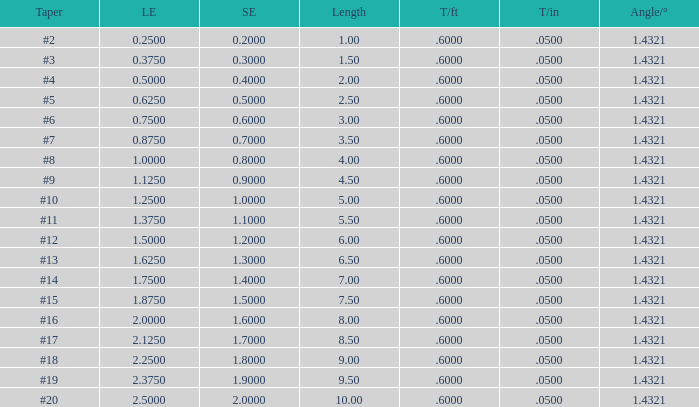Which Large end has a Taper/ft smaller than 0.6000000000000001? 19.0. 